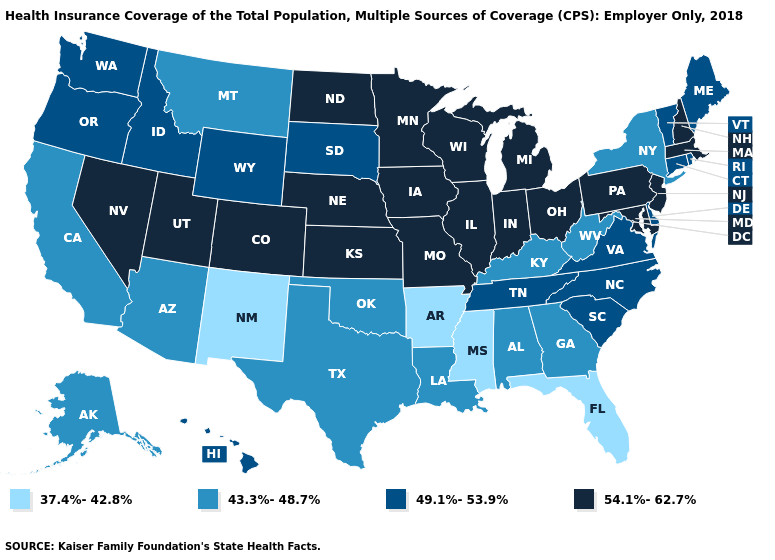Which states hav the highest value in the South?
Write a very short answer. Maryland. What is the value of Virginia?
Quick response, please. 49.1%-53.9%. Is the legend a continuous bar?
Keep it brief. No. Name the states that have a value in the range 49.1%-53.9%?
Short answer required. Connecticut, Delaware, Hawaii, Idaho, Maine, North Carolina, Oregon, Rhode Island, South Carolina, South Dakota, Tennessee, Vermont, Virginia, Washington, Wyoming. What is the value of Georgia?
Keep it brief. 43.3%-48.7%. Among the states that border Arizona , which have the highest value?
Be succinct. Colorado, Nevada, Utah. Does Oklahoma have the highest value in the South?
Write a very short answer. No. What is the value of Massachusetts?
Quick response, please. 54.1%-62.7%. Does West Virginia have a higher value than Florida?
Short answer required. Yes. What is the highest value in the USA?
Write a very short answer. 54.1%-62.7%. Name the states that have a value in the range 49.1%-53.9%?
Write a very short answer. Connecticut, Delaware, Hawaii, Idaho, Maine, North Carolina, Oregon, Rhode Island, South Carolina, South Dakota, Tennessee, Vermont, Virginia, Washington, Wyoming. Name the states that have a value in the range 37.4%-42.8%?
Be succinct. Arkansas, Florida, Mississippi, New Mexico. Among the states that border North Dakota , does Minnesota have the lowest value?
Concise answer only. No. What is the value of Massachusetts?
Short answer required. 54.1%-62.7%. Name the states that have a value in the range 49.1%-53.9%?
Keep it brief. Connecticut, Delaware, Hawaii, Idaho, Maine, North Carolina, Oregon, Rhode Island, South Carolina, South Dakota, Tennessee, Vermont, Virginia, Washington, Wyoming. 